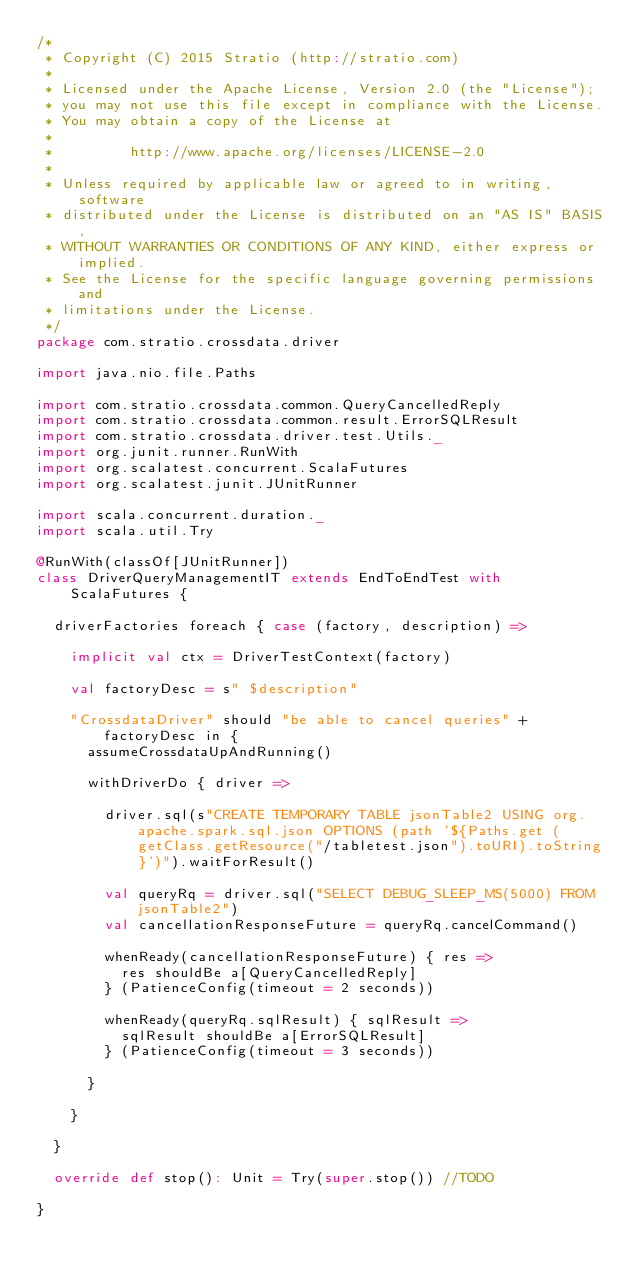Convert code to text. <code><loc_0><loc_0><loc_500><loc_500><_Scala_>/*
 * Copyright (C) 2015 Stratio (http://stratio.com)
 *
 * Licensed under the Apache License, Version 2.0 (the "License");
 * you may not use this file except in compliance with the License.
 * You may obtain a copy of the License at
 *
 *         http://www.apache.org/licenses/LICENSE-2.0
 *
 * Unless required by applicable law or agreed to in writing, software
 * distributed under the License is distributed on an "AS IS" BASIS,
 * WITHOUT WARRANTIES OR CONDITIONS OF ANY KIND, either express or implied.
 * See the License for the specific language governing permissions and
 * limitations under the License.
 */
package com.stratio.crossdata.driver

import java.nio.file.Paths

import com.stratio.crossdata.common.QueryCancelledReply
import com.stratio.crossdata.common.result.ErrorSQLResult
import com.stratio.crossdata.driver.test.Utils._
import org.junit.runner.RunWith
import org.scalatest.concurrent.ScalaFutures
import org.scalatest.junit.JUnitRunner

import scala.concurrent.duration._
import scala.util.Try

@RunWith(classOf[JUnitRunner])
class DriverQueryManagementIT extends EndToEndTest with ScalaFutures {

  driverFactories foreach { case (factory, description) =>

    implicit val ctx = DriverTestContext(factory)

    val factoryDesc = s" $description"

    "CrossdataDriver" should "be able to cancel queries" + factoryDesc in {
      assumeCrossdataUpAndRunning()

      withDriverDo { driver =>

        driver.sql(s"CREATE TEMPORARY TABLE jsonTable2 USING org.apache.spark.sql.json OPTIONS (path '${Paths.get (getClass.getResource("/tabletest.json").toURI).toString}')").waitForResult()

        val queryRq = driver.sql("SELECT DEBUG_SLEEP_MS(5000) FROM jsonTable2")
        val cancellationResponseFuture = queryRq.cancelCommand()

        whenReady(cancellationResponseFuture) { res =>
          res shouldBe a[QueryCancelledReply]
        } (PatienceConfig(timeout = 2 seconds))

        whenReady(queryRq.sqlResult) { sqlResult =>
          sqlResult shouldBe a[ErrorSQLResult]
        } (PatienceConfig(timeout = 3 seconds))

      }

    }

  }

  override def stop(): Unit = Try(super.stop()) //TODO

}
</code> 